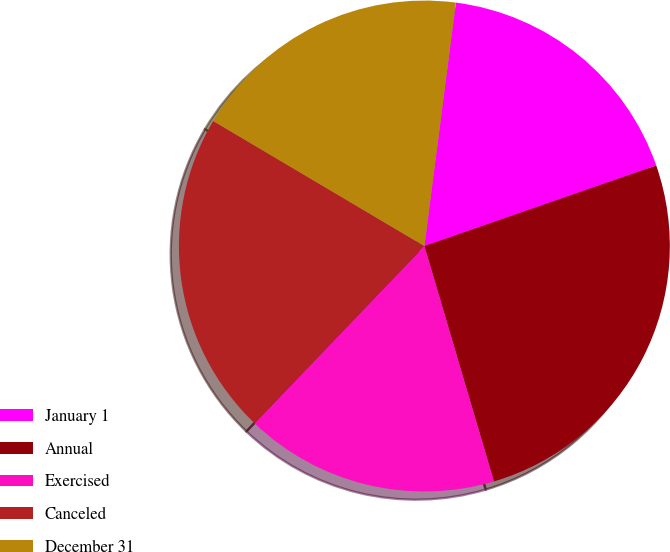<chart> <loc_0><loc_0><loc_500><loc_500><pie_chart><fcel>January 1<fcel>Annual<fcel>Exercised<fcel>Canceled<fcel>December 31<nl><fcel>17.63%<fcel>25.75%<fcel>16.73%<fcel>21.35%<fcel>18.54%<nl></chart> 